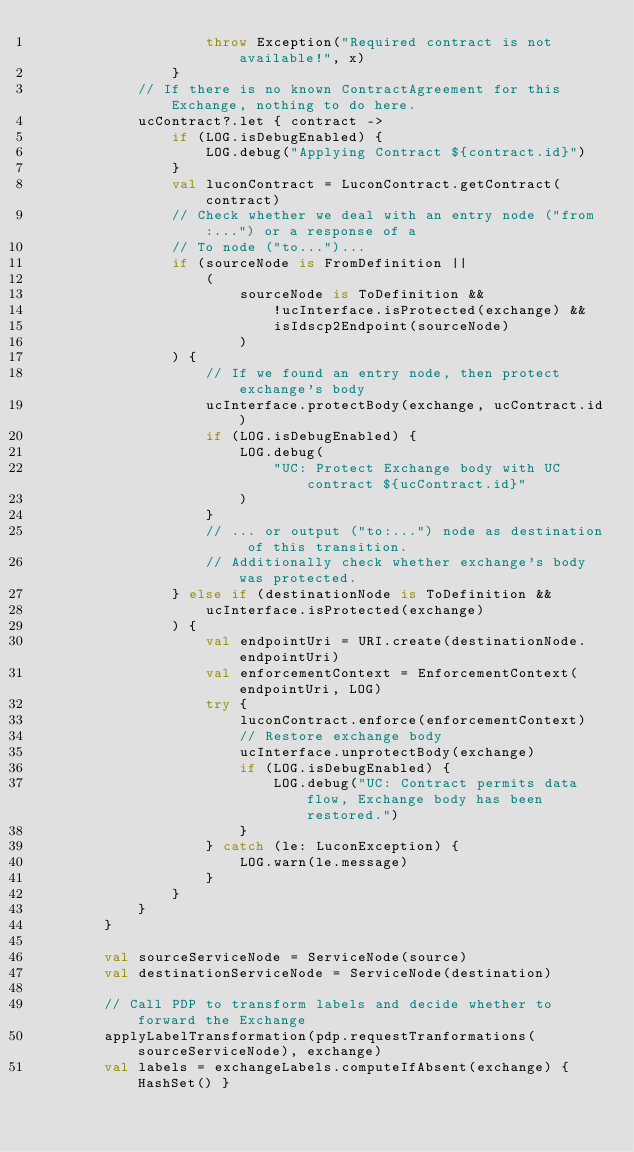<code> <loc_0><loc_0><loc_500><loc_500><_Kotlin_>                    throw Exception("Required contract is not available!", x)
                }
            // If there is no known ContractAgreement for this Exchange, nothing to do here.
            ucContract?.let { contract ->
                if (LOG.isDebugEnabled) {
                    LOG.debug("Applying Contract ${contract.id}")
                }
                val luconContract = LuconContract.getContract(contract)
                // Check whether we deal with an entry node ("from:...") or a response of a
                // To node ("to...")...
                if (sourceNode is FromDefinition ||
                    (
                        sourceNode is ToDefinition &&
                            !ucInterface.isProtected(exchange) &&
                            isIdscp2Endpoint(sourceNode)
                        )
                ) {
                    // If we found an entry node, then protect exchange's body
                    ucInterface.protectBody(exchange, ucContract.id)
                    if (LOG.isDebugEnabled) {
                        LOG.debug(
                            "UC: Protect Exchange body with UC contract ${ucContract.id}"
                        )
                    }
                    // ... or output ("to:...") node as destination of this transition.
                    // Additionally check whether exchange's body was protected.
                } else if (destinationNode is ToDefinition &&
                    ucInterface.isProtected(exchange)
                ) {
                    val endpointUri = URI.create(destinationNode.endpointUri)
                    val enforcementContext = EnforcementContext(endpointUri, LOG)
                    try {
                        luconContract.enforce(enforcementContext)
                        // Restore exchange body
                        ucInterface.unprotectBody(exchange)
                        if (LOG.isDebugEnabled) {
                            LOG.debug("UC: Contract permits data flow, Exchange body has been restored.")
                        }
                    } catch (le: LuconException) {
                        LOG.warn(le.message)
                    }
                }
            }
        }

        val sourceServiceNode = ServiceNode(source)
        val destinationServiceNode = ServiceNode(destination)

        // Call PDP to transform labels and decide whether to forward the Exchange
        applyLabelTransformation(pdp.requestTranformations(sourceServiceNode), exchange)
        val labels = exchangeLabels.computeIfAbsent(exchange) { HashSet() }</code> 